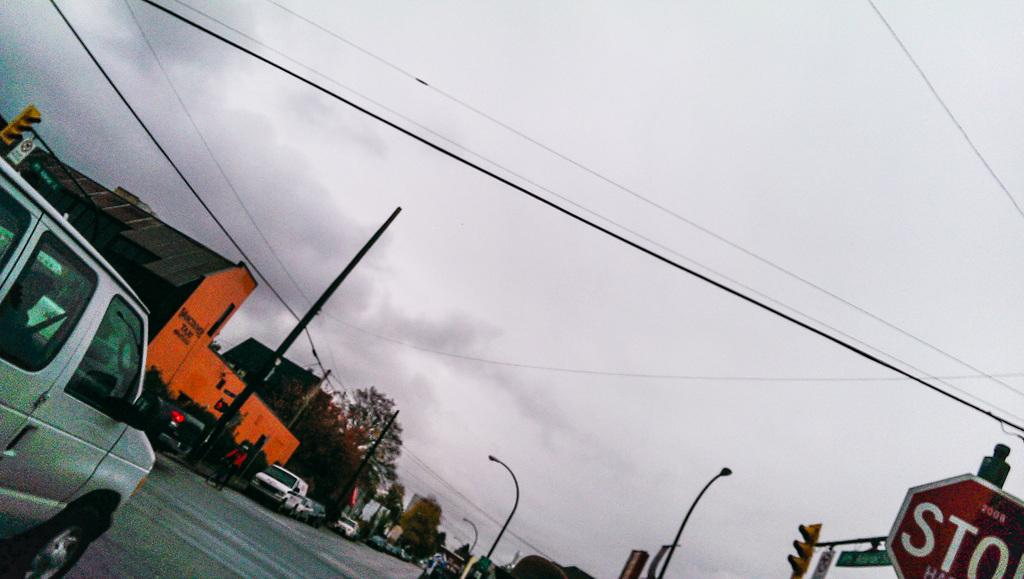What is happening on the road in the image? There are vehicles moving on the road in the image. Are there any vehicles not moving in the image? Yes, some vehicles are parked in the image. What can be seen in the image besides vehicles? There are poles, trees, and buildings in the image. What is the condition of the sky in the image? The sky is clear in the image. Can you see any mountains in the image? There are no mountains visible in the image. How much growth has the robin experienced in the image? There is no robin present in the image, so it is not possible to determine its growth. 